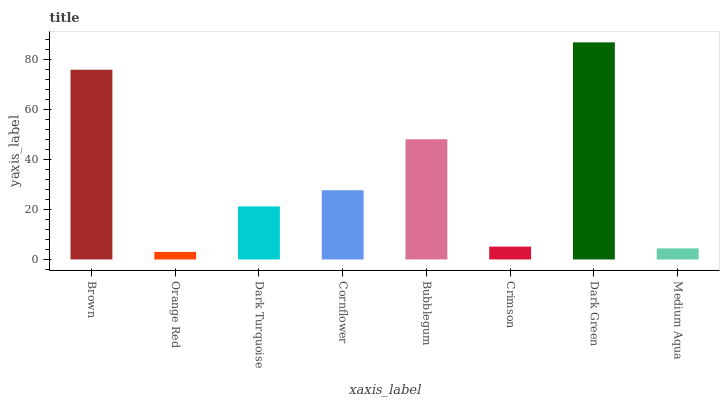Is Orange Red the minimum?
Answer yes or no. Yes. Is Dark Green the maximum?
Answer yes or no. Yes. Is Dark Turquoise the minimum?
Answer yes or no. No. Is Dark Turquoise the maximum?
Answer yes or no. No. Is Dark Turquoise greater than Orange Red?
Answer yes or no. Yes. Is Orange Red less than Dark Turquoise?
Answer yes or no. Yes. Is Orange Red greater than Dark Turquoise?
Answer yes or no. No. Is Dark Turquoise less than Orange Red?
Answer yes or no. No. Is Cornflower the high median?
Answer yes or no. Yes. Is Dark Turquoise the low median?
Answer yes or no. Yes. Is Crimson the high median?
Answer yes or no. No. Is Dark Green the low median?
Answer yes or no. No. 